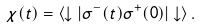Convert formula to latex. <formula><loc_0><loc_0><loc_500><loc_500>\chi ( t ) = \langle \downarrow | \sigma ^ { - } ( t ) \sigma ^ { + } ( 0 ) | \downarrow \rangle \, .</formula> 